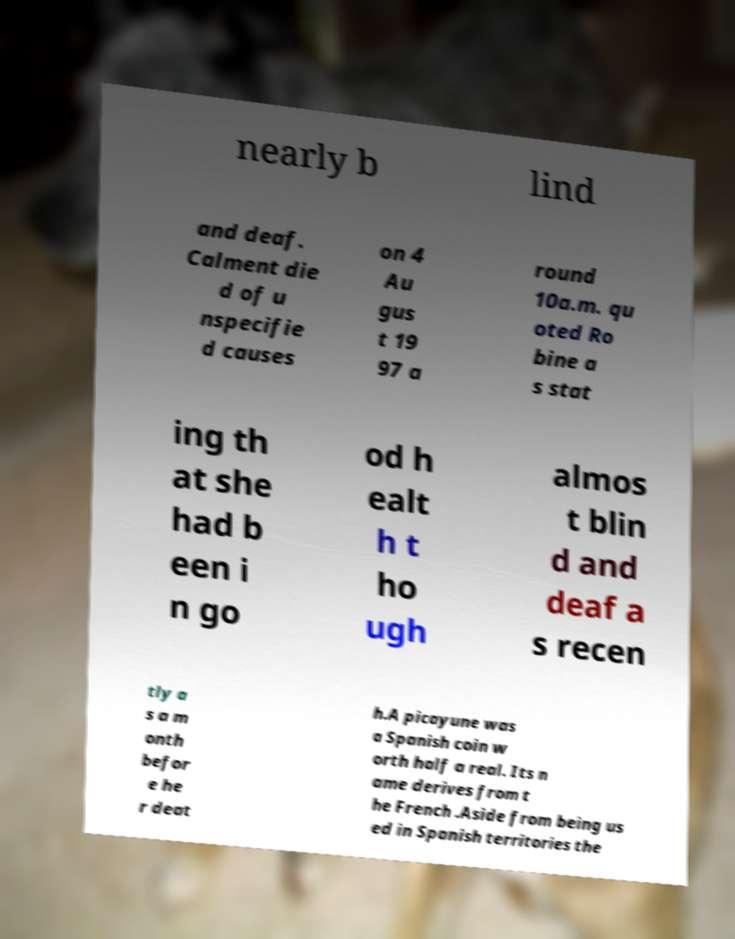For documentation purposes, I need the text within this image transcribed. Could you provide that? nearly b lind and deaf. Calment die d of u nspecifie d causes on 4 Au gus t 19 97 a round 10a.m. qu oted Ro bine a s stat ing th at she had b een i n go od h ealt h t ho ugh almos t blin d and deaf a s recen tly a s a m onth befor e he r deat h.A picayune was a Spanish coin w orth half a real. Its n ame derives from t he French .Aside from being us ed in Spanish territories the 